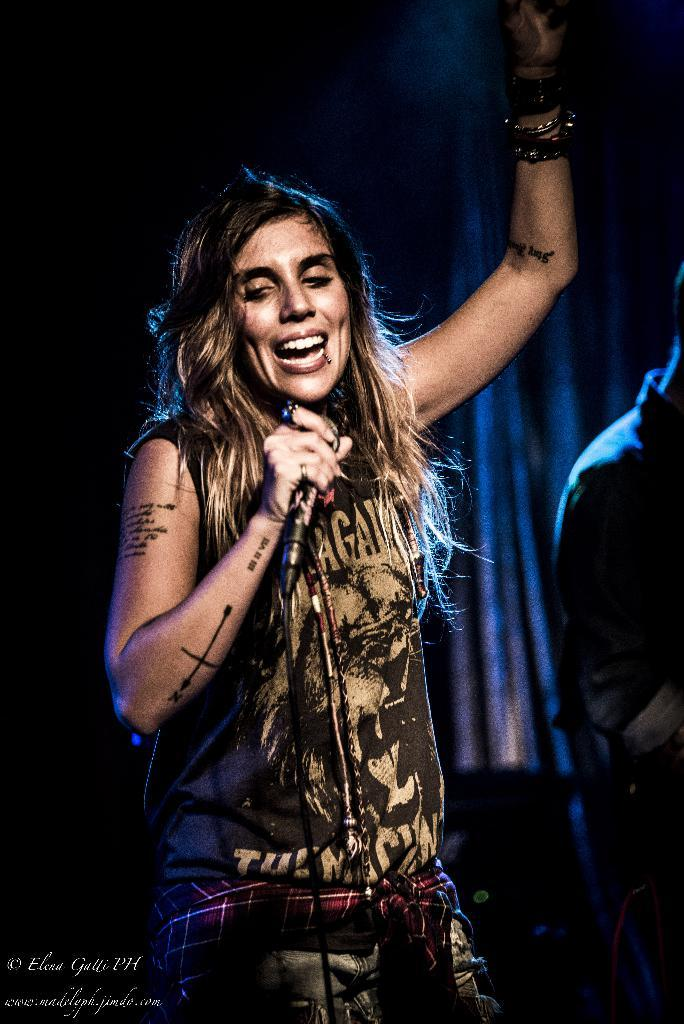What is the main subject of the image? There is a woman in the image. What is the woman doing in the image? The woman is standing and singing. What object is the woman holding in the image? The woman is holding a microphone. Can you describe the background of the image? The background is dark. Are there any other people visible in the image? Yes, there is another person in the background of the image. What type of dress is the worm wearing in the image? There is no worm or dress present in the image. 